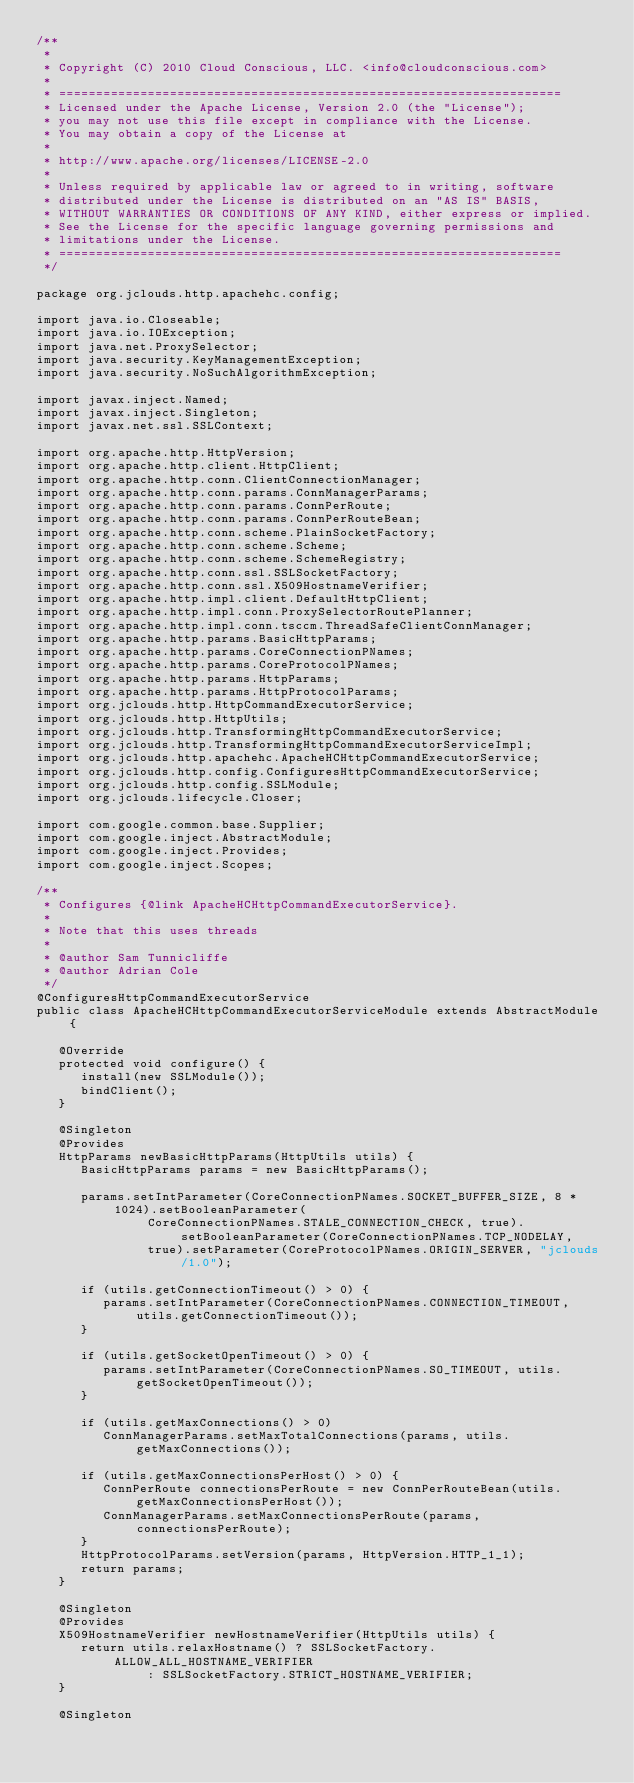<code> <loc_0><loc_0><loc_500><loc_500><_Java_>/**
 *
 * Copyright (C) 2010 Cloud Conscious, LLC. <info@cloudconscious.com>
 *
 * ====================================================================
 * Licensed under the Apache License, Version 2.0 (the "License");
 * you may not use this file except in compliance with the License.
 * You may obtain a copy of the License at
 *
 * http://www.apache.org/licenses/LICENSE-2.0
 *
 * Unless required by applicable law or agreed to in writing, software
 * distributed under the License is distributed on an "AS IS" BASIS,
 * WITHOUT WARRANTIES OR CONDITIONS OF ANY KIND, either express or implied.
 * See the License for the specific language governing permissions and
 * limitations under the License.
 * ====================================================================
 */

package org.jclouds.http.apachehc.config;

import java.io.Closeable;
import java.io.IOException;
import java.net.ProxySelector;
import java.security.KeyManagementException;
import java.security.NoSuchAlgorithmException;

import javax.inject.Named;
import javax.inject.Singleton;
import javax.net.ssl.SSLContext;

import org.apache.http.HttpVersion;
import org.apache.http.client.HttpClient;
import org.apache.http.conn.ClientConnectionManager;
import org.apache.http.conn.params.ConnManagerParams;
import org.apache.http.conn.params.ConnPerRoute;
import org.apache.http.conn.params.ConnPerRouteBean;
import org.apache.http.conn.scheme.PlainSocketFactory;
import org.apache.http.conn.scheme.Scheme;
import org.apache.http.conn.scheme.SchemeRegistry;
import org.apache.http.conn.ssl.SSLSocketFactory;
import org.apache.http.conn.ssl.X509HostnameVerifier;
import org.apache.http.impl.client.DefaultHttpClient;
import org.apache.http.impl.conn.ProxySelectorRoutePlanner;
import org.apache.http.impl.conn.tsccm.ThreadSafeClientConnManager;
import org.apache.http.params.BasicHttpParams;
import org.apache.http.params.CoreConnectionPNames;
import org.apache.http.params.CoreProtocolPNames;
import org.apache.http.params.HttpParams;
import org.apache.http.params.HttpProtocolParams;
import org.jclouds.http.HttpCommandExecutorService;
import org.jclouds.http.HttpUtils;
import org.jclouds.http.TransformingHttpCommandExecutorService;
import org.jclouds.http.TransformingHttpCommandExecutorServiceImpl;
import org.jclouds.http.apachehc.ApacheHCHttpCommandExecutorService;
import org.jclouds.http.config.ConfiguresHttpCommandExecutorService;
import org.jclouds.http.config.SSLModule;
import org.jclouds.lifecycle.Closer;

import com.google.common.base.Supplier;
import com.google.inject.AbstractModule;
import com.google.inject.Provides;
import com.google.inject.Scopes;

/**
 * Configures {@link ApacheHCHttpCommandExecutorService}.
 * 
 * Note that this uses threads
 * 
 * @author Sam Tunnicliffe
 * @author Adrian Cole
 */
@ConfiguresHttpCommandExecutorService
public class ApacheHCHttpCommandExecutorServiceModule extends AbstractModule {

   @Override
   protected void configure() {
      install(new SSLModule());
      bindClient();
   }

   @Singleton
   @Provides
   HttpParams newBasicHttpParams(HttpUtils utils) {
      BasicHttpParams params = new BasicHttpParams();

      params.setIntParameter(CoreConnectionPNames.SOCKET_BUFFER_SIZE, 8 * 1024).setBooleanParameter(
               CoreConnectionPNames.STALE_CONNECTION_CHECK, true).setBooleanParameter(CoreConnectionPNames.TCP_NODELAY,
               true).setParameter(CoreProtocolPNames.ORIGIN_SERVER, "jclouds/1.0");

      if (utils.getConnectionTimeout() > 0) {
         params.setIntParameter(CoreConnectionPNames.CONNECTION_TIMEOUT, utils.getConnectionTimeout());
      }

      if (utils.getSocketOpenTimeout() > 0) {
         params.setIntParameter(CoreConnectionPNames.SO_TIMEOUT, utils.getSocketOpenTimeout());
      }

      if (utils.getMaxConnections() > 0)
         ConnManagerParams.setMaxTotalConnections(params, utils.getMaxConnections());

      if (utils.getMaxConnectionsPerHost() > 0) {
         ConnPerRoute connectionsPerRoute = new ConnPerRouteBean(utils.getMaxConnectionsPerHost());
         ConnManagerParams.setMaxConnectionsPerRoute(params, connectionsPerRoute);
      }
      HttpProtocolParams.setVersion(params, HttpVersion.HTTP_1_1);
      return params;
   }

   @Singleton
   @Provides
   X509HostnameVerifier newHostnameVerifier(HttpUtils utils) {
      return utils.relaxHostname() ? SSLSocketFactory.ALLOW_ALL_HOSTNAME_VERIFIER
               : SSLSocketFactory.STRICT_HOSTNAME_VERIFIER;
   }

   @Singleton</code> 